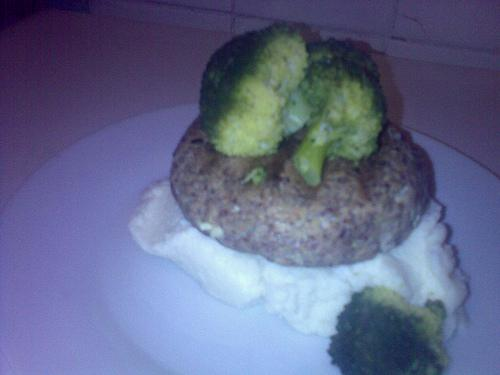Question: how many broccoli florets are in the picture?
Choices:
A. Two.
B. Four.
C. Three.
D. Five.
Answer with the letter. Answer: C 